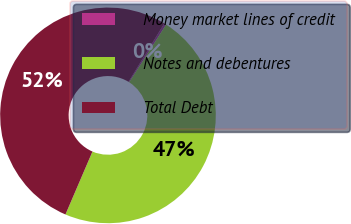Convert chart to OTSL. <chart><loc_0><loc_0><loc_500><loc_500><pie_chart><fcel>Money market lines of credit<fcel>Notes and debentures<fcel>Total Debt<nl><fcel>0.32%<fcel>47.38%<fcel>52.29%<nl></chart> 